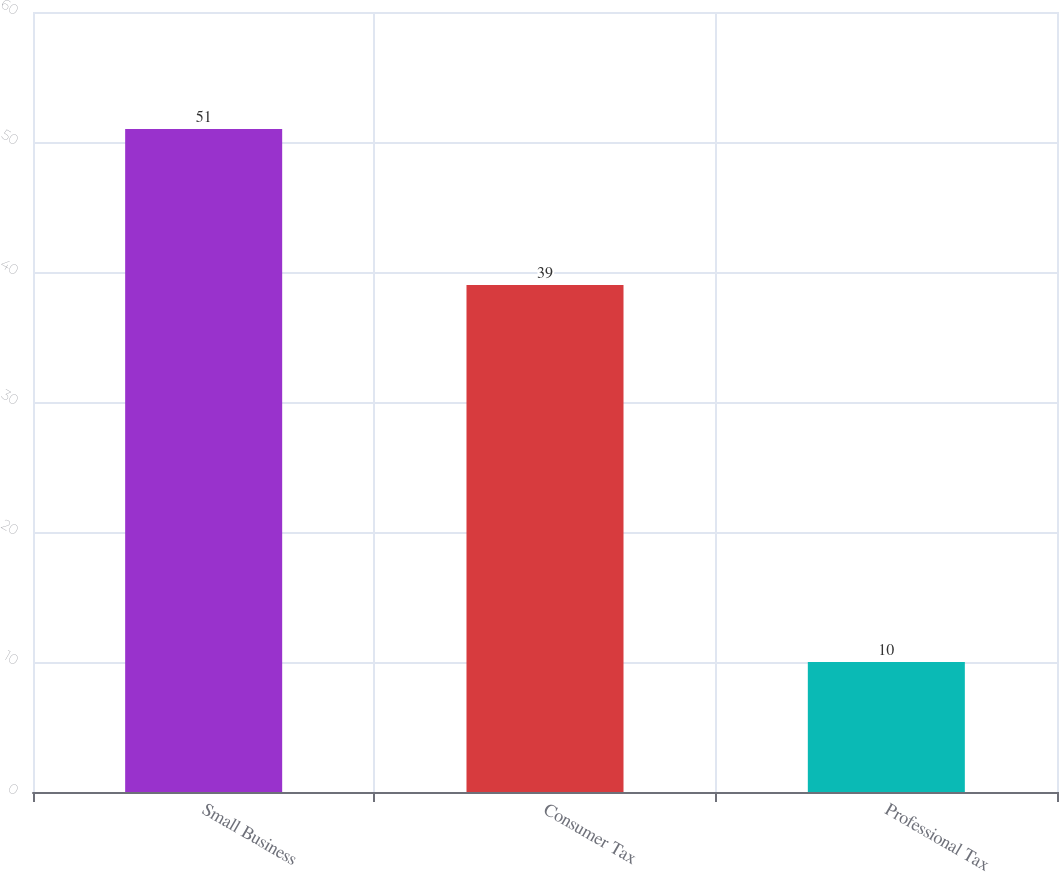Convert chart. <chart><loc_0><loc_0><loc_500><loc_500><bar_chart><fcel>Small Business<fcel>Consumer Tax<fcel>Professional Tax<nl><fcel>51<fcel>39<fcel>10<nl></chart> 